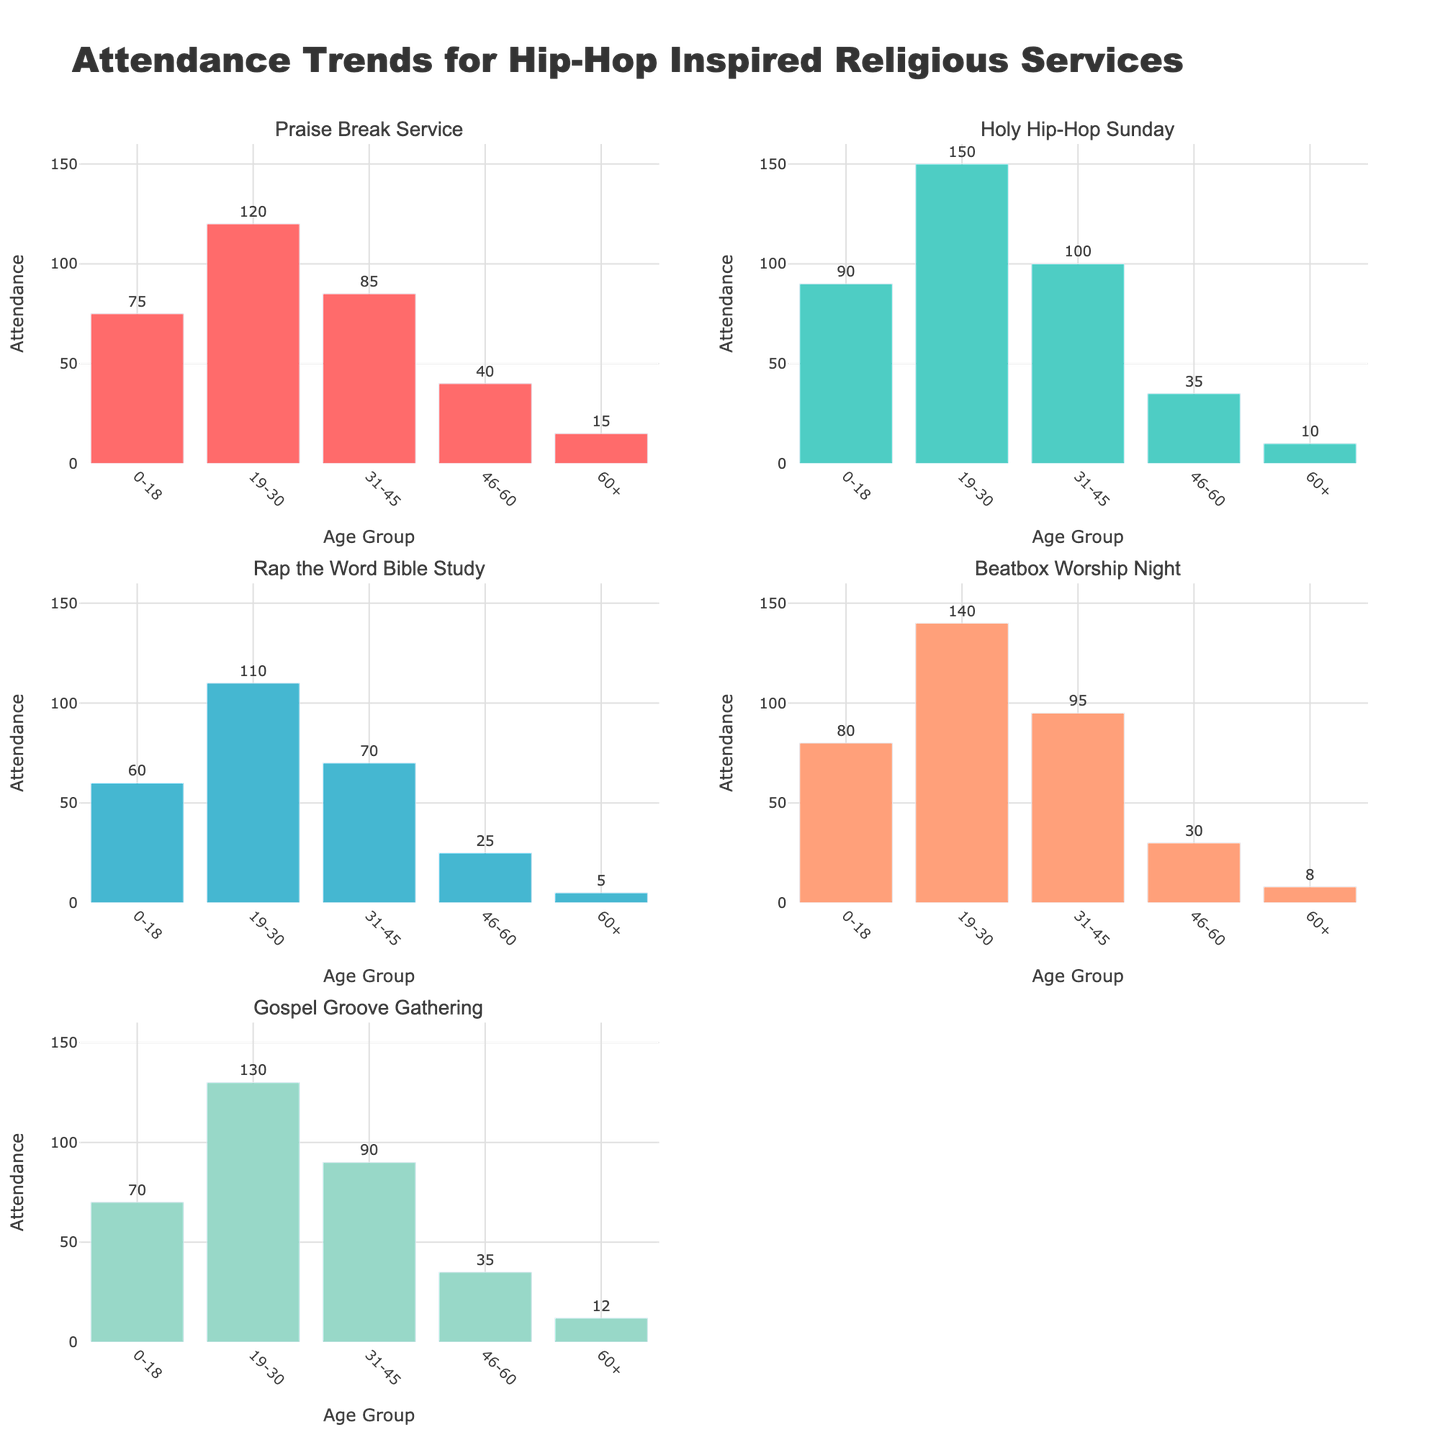What is the title of the figure? The title is located at the top of the figure and clearly states the overall subject.
Answer: Attendance Trends for Hip-Hop Inspired Religious Services Which service has the highest attendance in the "19-30" age group? Looking at the subplots, "Holy Hip-Hop Sunday" has the highest bar for the "19-30" age group.
Answer: Holy Hip-Hop Sunday Among the age groups, how does the "60+" group's attendance generally compare across different services? Each subplot shows the "60+" group's attendance. Overall, their attendance is consistently the lowest for all services.
Answer: Lowest What is the attendance difference between "Praise Break" Service and "Gospel Groove Gathering" for the "31-45" age group? From the subplots, the attendance is 85 for "Praise Break" and 90 for "Gospel Groove Gathering". The difference is calculated as 90 - 85.
Answer: 5 Which service has the overall lowest attendance across all age groups? By examining the subplots, "Rap the Word" Bible Study has the lowest attendance values across each age group.
Answer: Rap the Word Bible Study Compare the attendance of "Beatbox Worship Night" and "Gospel Groove Gathering" for the "0-18" age group. Which one is higher and by how much? "Beatbox Worship Night" has an attendance of 80 and "Gospel Groove Gathering" has 70 for the "0-18" age group. The difference is 10.
Answer: Beatbox Worship Night by 10 What trend can be observed for the "46-60" age group across all services? In each subplot, attendance for the "46-60" age group is consistently lower compared to younger age groups except "60+".
Answer: Consistently lower Calculate the average attendance of the "19-30" age group across all services. Attendance values are 120, 150, 110, 140, and 130. Sum them up as 650, then divide by 5 to get the average.
Answer: 130 What is the range of attendance for the "0-18" age group across different services? Attendance values for "0-18" are 75, 90, 60, 80, and 70. The maximum is 90 and the minimum is 60. The range is the difference, 90 - 60.
Answer: 30 